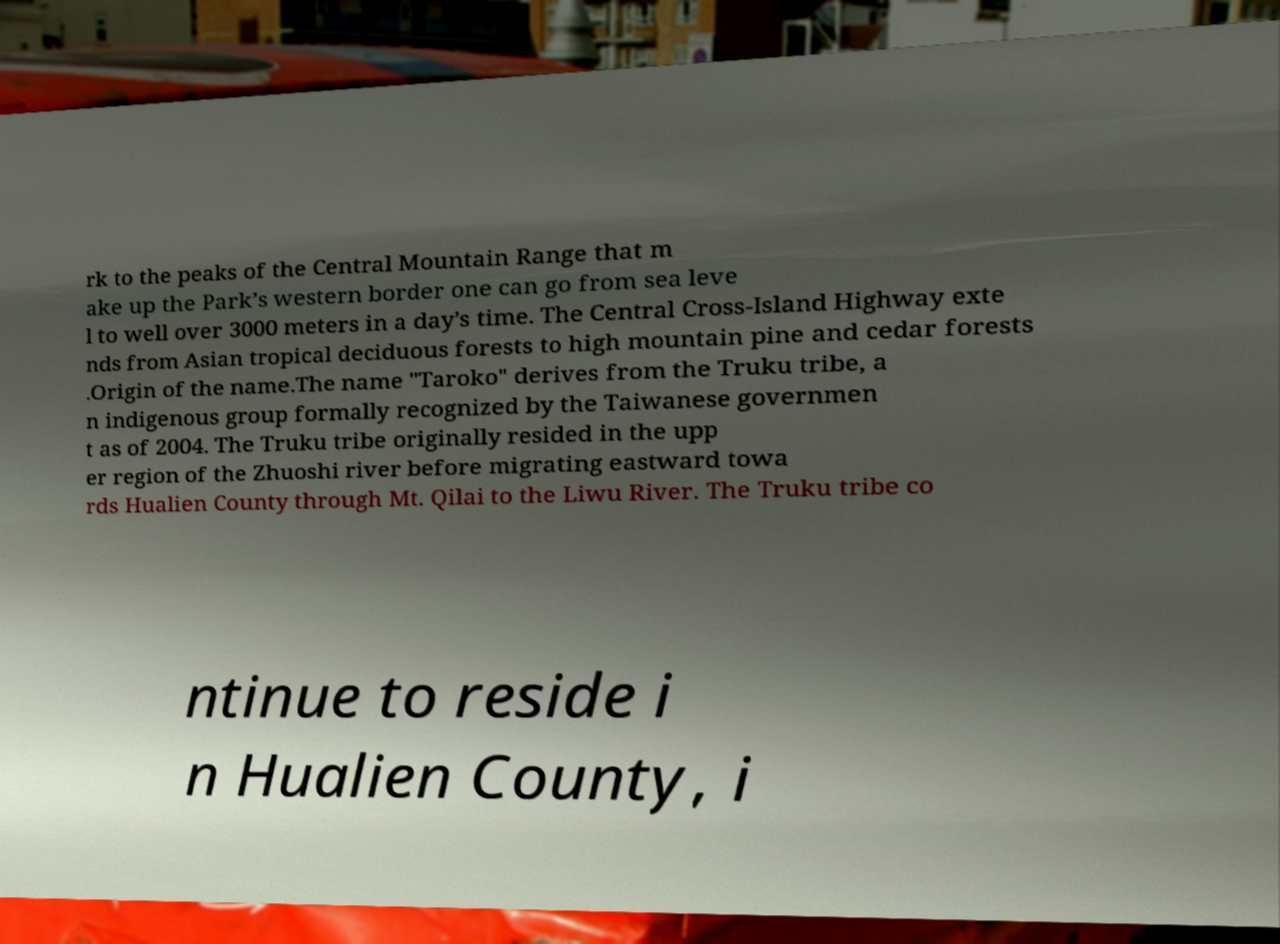I need the written content from this picture converted into text. Can you do that? rk to the peaks of the Central Mountain Range that m ake up the Park’s western border one can go from sea leve l to well over 3000 meters in a day’s time. The Central Cross-Island Highway exte nds from Asian tropical deciduous forests to high mountain pine and cedar forests .Origin of the name.The name "Taroko" derives from the Truku tribe, a n indigenous group formally recognized by the Taiwanese governmen t as of 2004. The Truku tribe originally resided in the upp er region of the Zhuoshi river before migrating eastward towa rds Hualien County through Mt. Qilai to the Liwu River. The Truku tribe co ntinue to reside i n Hualien County, i 